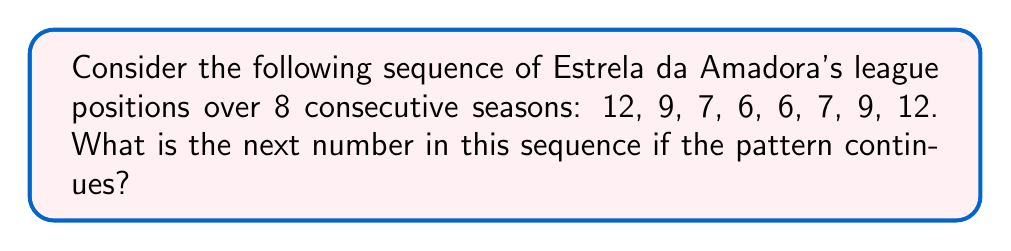Teach me how to tackle this problem. To solve this problem, let's analyze the sequence step-by-step:

1) First, let's write out the sequence:
   12, 9, 7, 6, 6, 7, 9, 12

2) Observe that the sequence is symmetric. It decreases, reaches a minimum, then increases back to the starting number.

3) We can represent this pattern mathematically:
   For $n = 1$ to $4$: $a_n = 13 - n$
   For $n = 5$ to $8$: $a_n = a_{9-n}$

4) This creates a palindromic sequence with 8 terms.

5) If we continue this pattern, the next term (9th term) would start the sequence over again.

6) Therefore, the 9th term would be equal to the 1st term.

7) The 1st term in the sequence is 12.

Thus, if the pattern continues, the next number in the sequence would be 12.
Answer: 12 